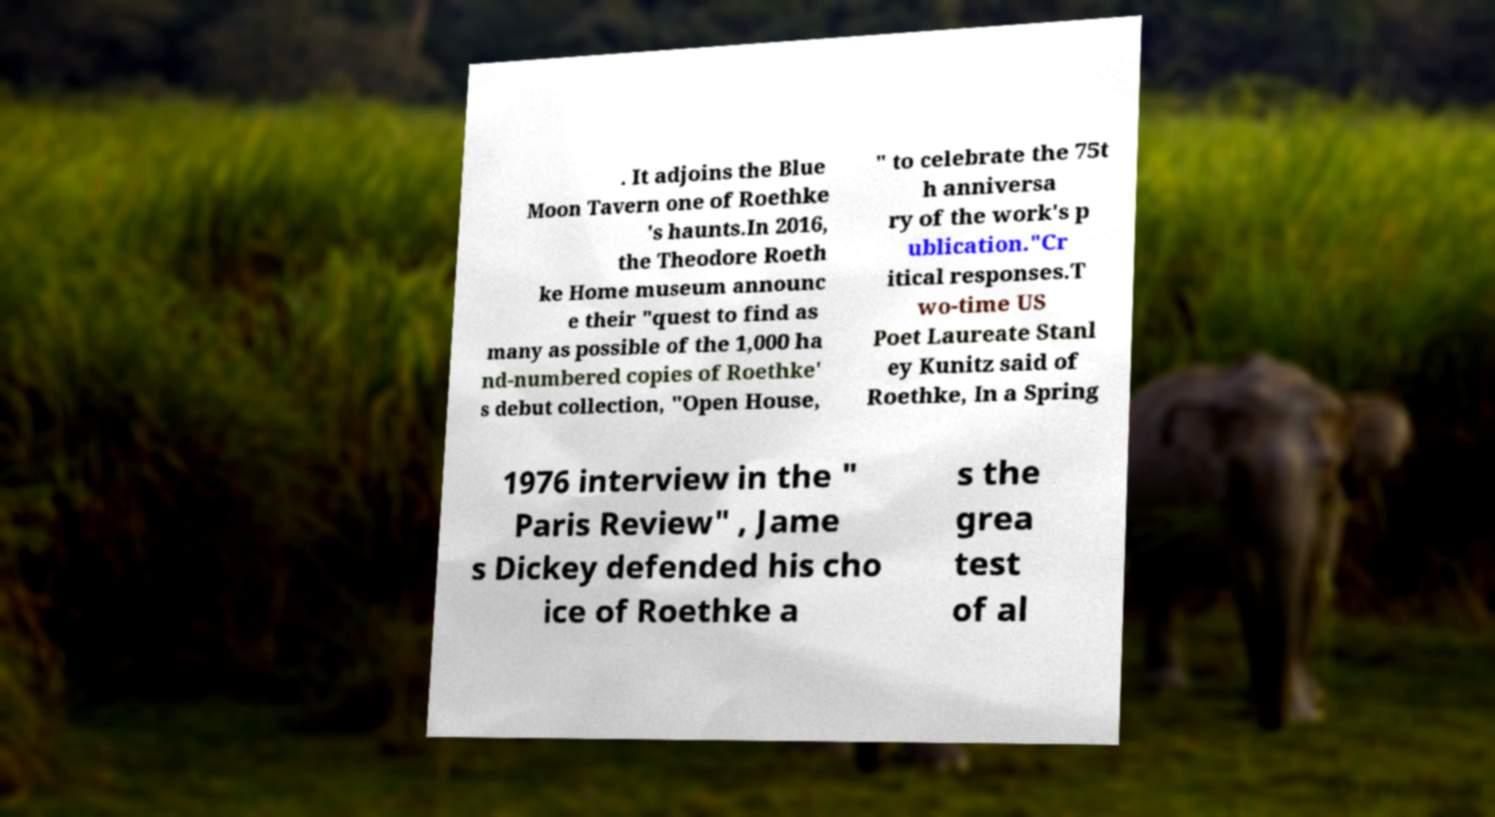Could you extract and type out the text from this image? . It adjoins the Blue Moon Tavern one of Roethke 's haunts.In 2016, the Theodore Roeth ke Home museum announc e their "quest to find as many as possible of the 1,000 ha nd-numbered copies of Roethke' s debut collection, "Open House, " to celebrate the 75t h anniversa ry of the work's p ublication."Cr itical responses.T wo-time US Poet Laureate Stanl ey Kunitz said of Roethke, In a Spring 1976 interview in the " Paris Review" , Jame s Dickey defended his cho ice of Roethke a s the grea test of al 